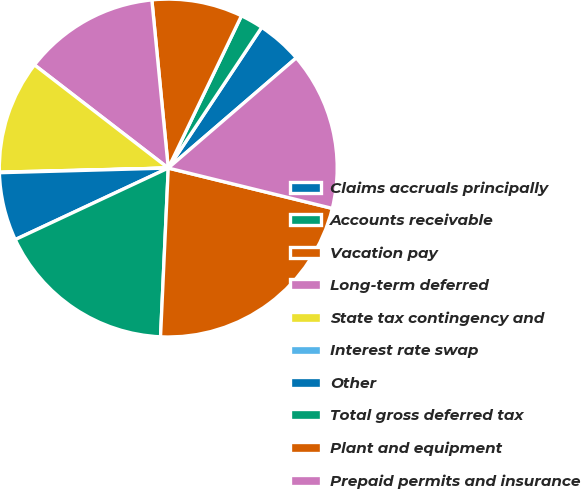Convert chart to OTSL. <chart><loc_0><loc_0><loc_500><loc_500><pie_chart><fcel>Claims accruals principally<fcel>Accounts receivable<fcel>Vacation pay<fcel>Long-term deferred<fcel>State tax contingency and<fcel>Interest rate swap<fcel>Other<fcel>Total gross deferred tax<fcel>Plant and equipment<fcel>Prepaid permits and insurance<nl><fcel>4.36%<fcel>2.2%<fcel>8.68%<fcel>13.0%<fcel>10.84%<fcel>0.05%<fcel>6.52%<fcel>17.31%<fcel>21.89%<fcel>15.15%<nl></chart> 